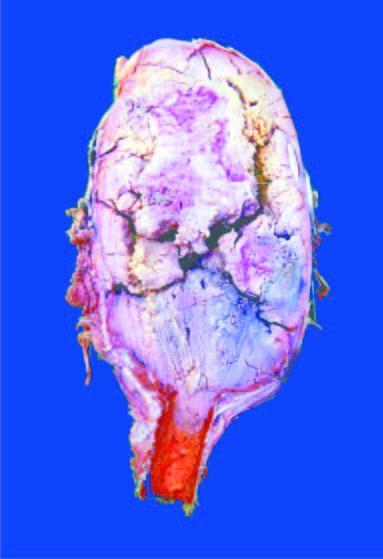what shows circumscribed, dark tan, haemorrhagic and necrotic tumour?
Answer the question using a single word or phrase. Sectioned surface 